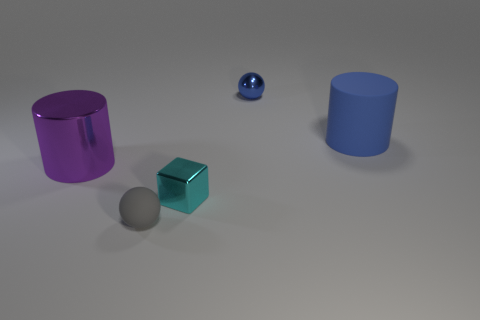Do the small metal sphere and the large rubber cylinder behind the small gray rubber ball have the same color?
Offer a very short reply. Yes. There is a small ball that is the same color as the large matte cylinder; what material is it?
Your answer should be compact. Metal. Is there anything else that is the same size as the matte sphere?
Provide a short and direct response. Yes. There is a object that is to the left of the tiny ball in front of the blue cylinder; what is it made of?
Provide a succinct answer. Metal. Is the number of purple objects that are on the left side of the large matte object greater than the number of large cylinders that are on the right side of the cyan object?
Offer a very short reply. No. The blue rubber cylinder is what size?
Give a very brief answer. Large. There is a big thing left of the tiny gray matte ball; does it have the same color as the tiny shiny cube?
Provide a succinct answer. No. Are there any other things that have the same shape as the small blue metal thing?
Provide a short and direct response. Yes. There is a small metal block that is in front of the shiny sphere; is there a cyan metallic thing left of it?
Your response must be concise. No. Are there fewer tiny blue metallic things left of the big metallic object than balls on the right side of the shiny block?
Your response must be concise. Yes. 